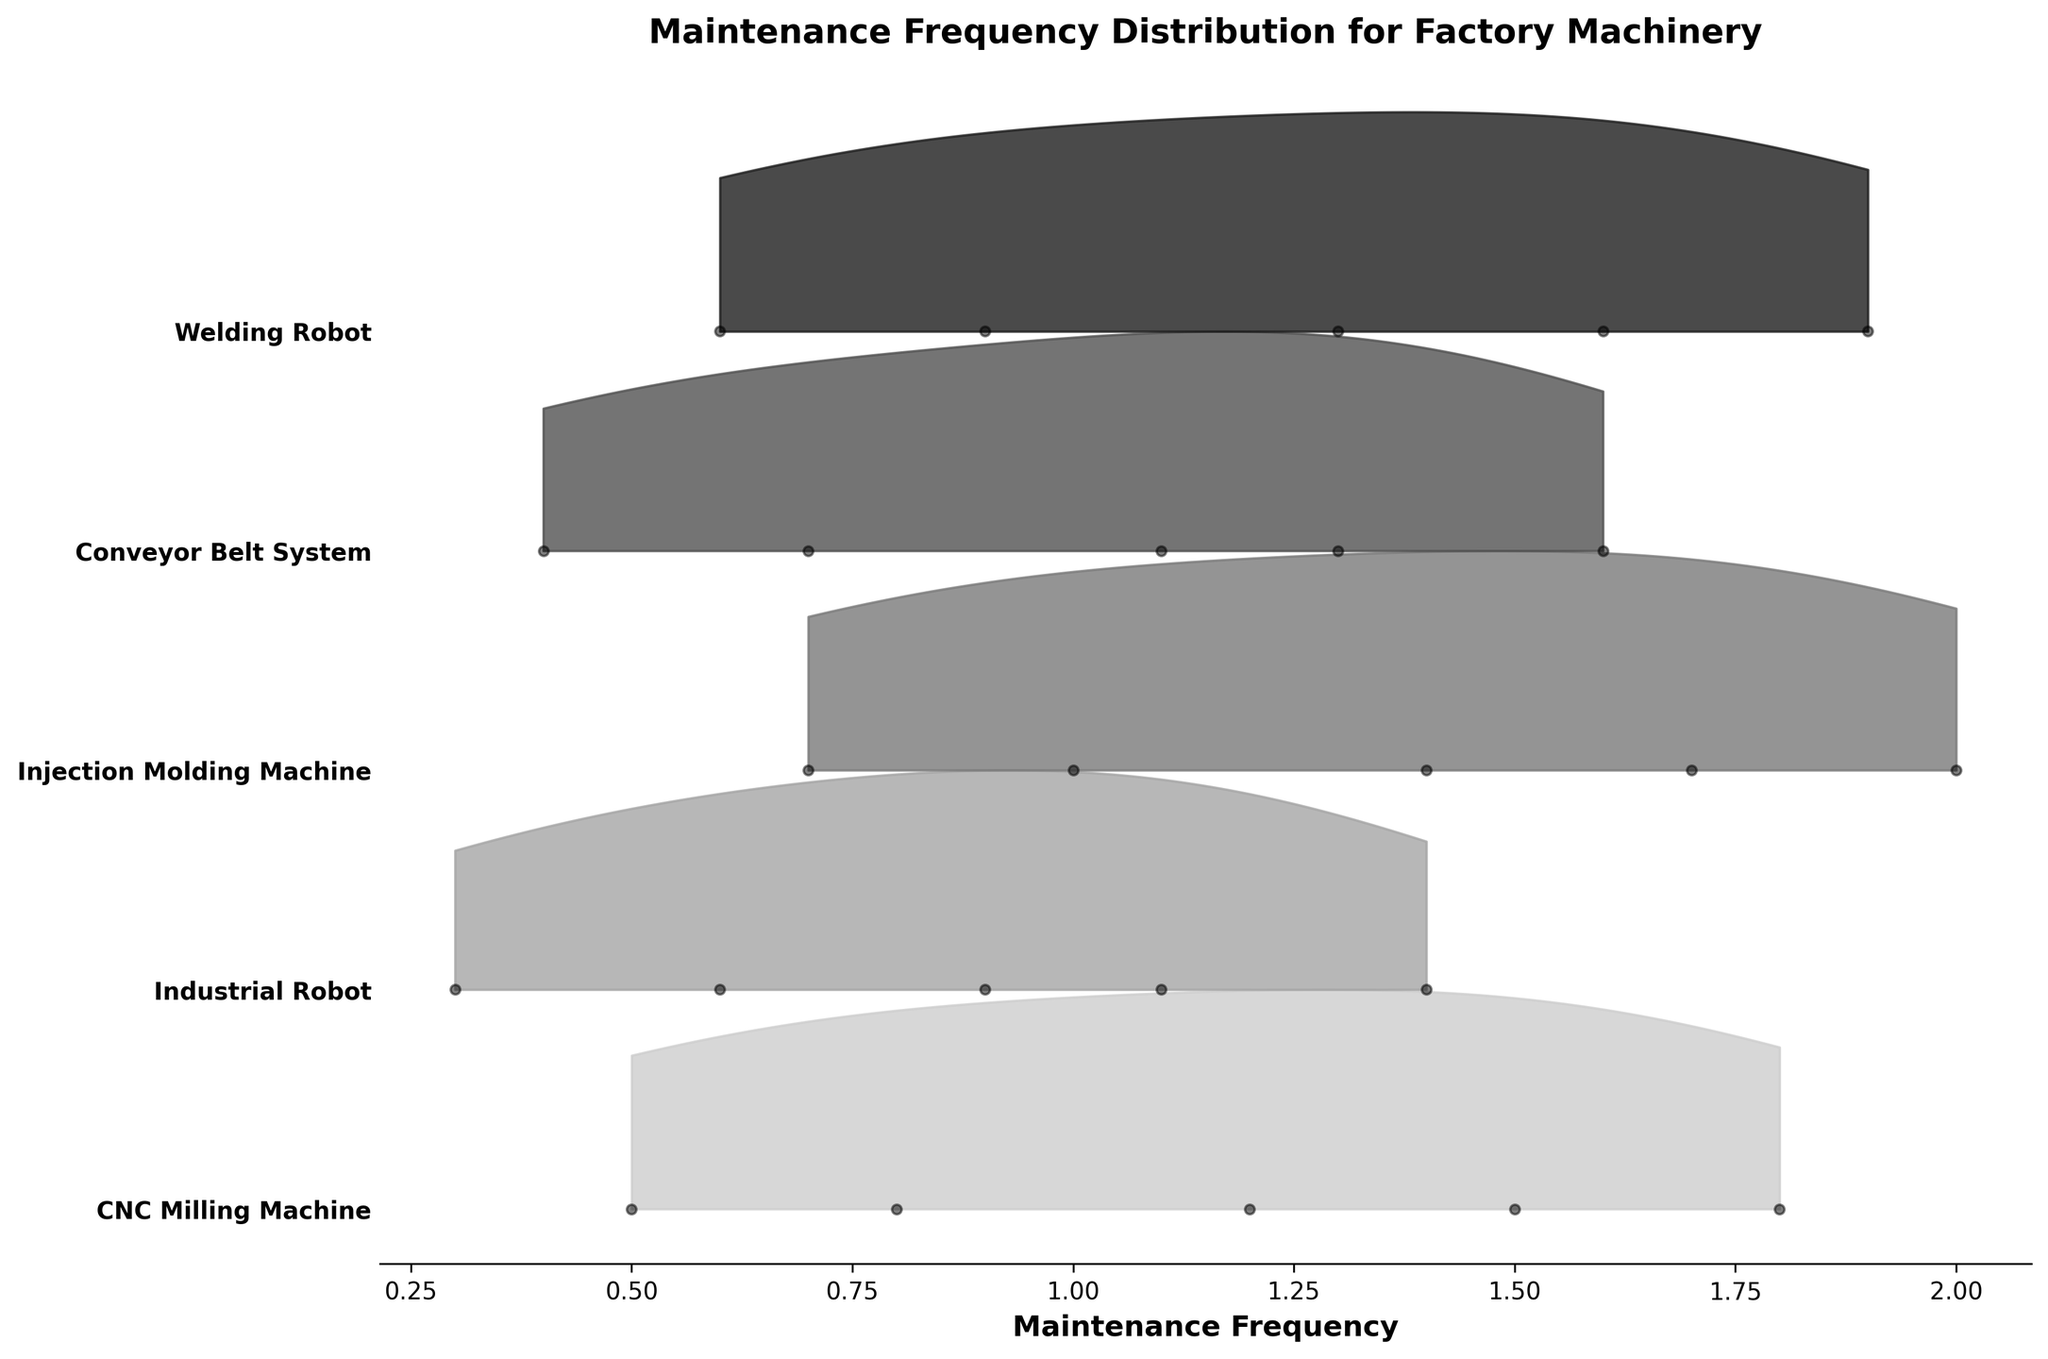What is the title of the plot? The title of the plot is usually prominently displayed at the top. In this case, it reads "Maintenance Frequency Distribution for Factory Machinery".
Answer: Maintenance Frequency Distribution for Factory Machinery How many different types of machines are represented in the plot? Each distinct machine type is delineated along the y-axis, each with a unique label. By counting these labels, we can determine there are five distinct machine types.
Answer: 5 Which machine type has the highest peak frequency in its ridgeline? Look for the highest point of the filled regions within each machine type's section. The "Injection Molding Machine" reaches a peak frequency close to the top, indicating the highest value.
Answer: Injection Molding Machine Does the CNC Milling Machine have a higher maintenance frequency in its 4th year compared to the Industrial Robot in its 4th year? Compare the position of the 4th-year dot for both machine types. The CNC Milling Machine in its 4th year has a dot at 1.5, while the Industrial Robot's 4th-year dot is at 1.1.
Answer: Yes Among these machines, which one shows the most consistent increase in maintenance frequency over the years? Observing the maintenance frequency trends over the years for each machine, the "Injection Molding Machine" shows a steady and consistent increase from year 1 to year 5.
Answer: Injection Molding Machine What is the range of maintenance frequency values for the Conveyor Belt System? For the Conveyor Belt System, identify the minimum and maximum values in its section of the plot, which can be seen as dots from 0.4 to 1.6.
Answer: 0.4 to 1.6 Which machine type shows the steepest increase in maintenance frequency between the 2nd and 3rd years? By comparing the vertical differences between year 2 and year 3 for each machine type, the "Injection Molding Machine" increases from 1.0 to 1.4, more than the others.
Answer: Injection Molding Machine What maintenance frequency corresponds to the 5th year for the Welding Robot? Locate the dot corresponding to the 5th year in the Welding Robot section, which is marked at a frequency of 1.9.
Answer: 1.9 How does the maintenance frequency distribution for the Industrial Robot compare to the CNC Milling Machine? By comparing the filled regions and dots, the Industrial Robot has a generally lower frequency distribution compared to the CNC Milling Machine over the same years.
Answer: Lower Which two machine types have the closest maintenance frequencies in their 3rd year? Examine the 3rd-year maintenance frequencies for each machine type. The CNC Milling Machine at 1.2 and the Welding Robot at 1.3 are the closest.
Answer: CNC Milling Machine and Welding Robot 